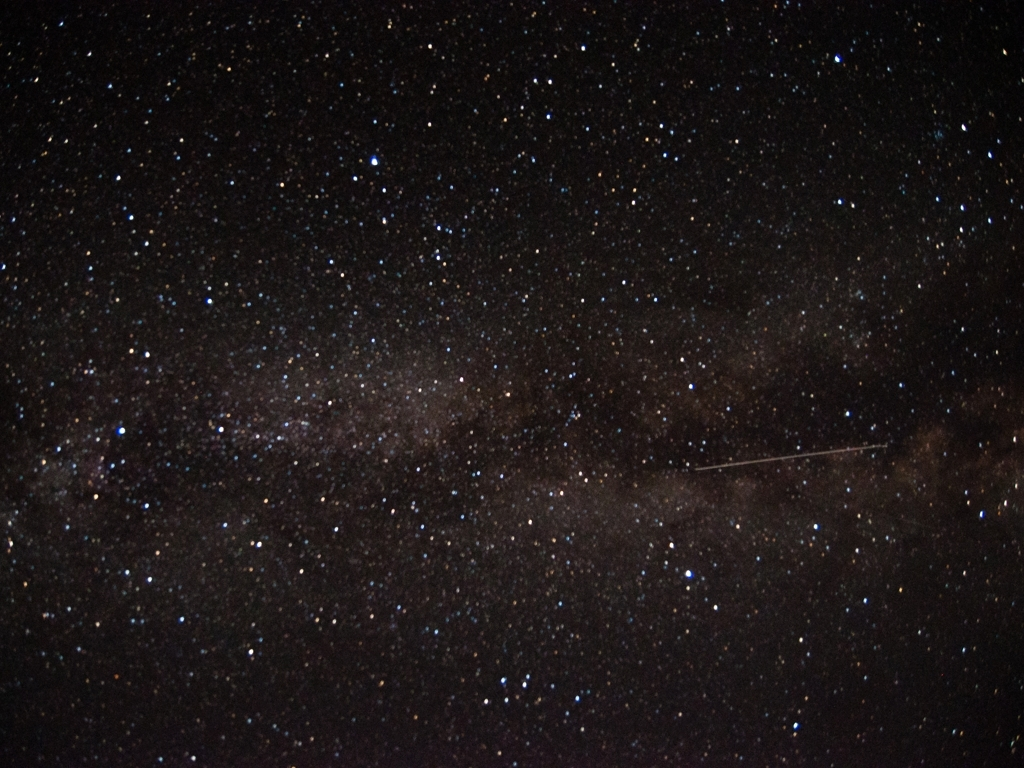What can this image tell us about our place in the universe? This image is a humbling representation of the vastness of the cosmos. Each point of light is a sun, many with their own planets, showcasing the sheer scale of our galaxy, which itself is just one of billions in the observable universe. Our solar system is a tiny speck within this grand tapestry. The image evokes a sense of wonder and invites reflection on the enormity and beauty of the cosmos, as well as our role in it. 